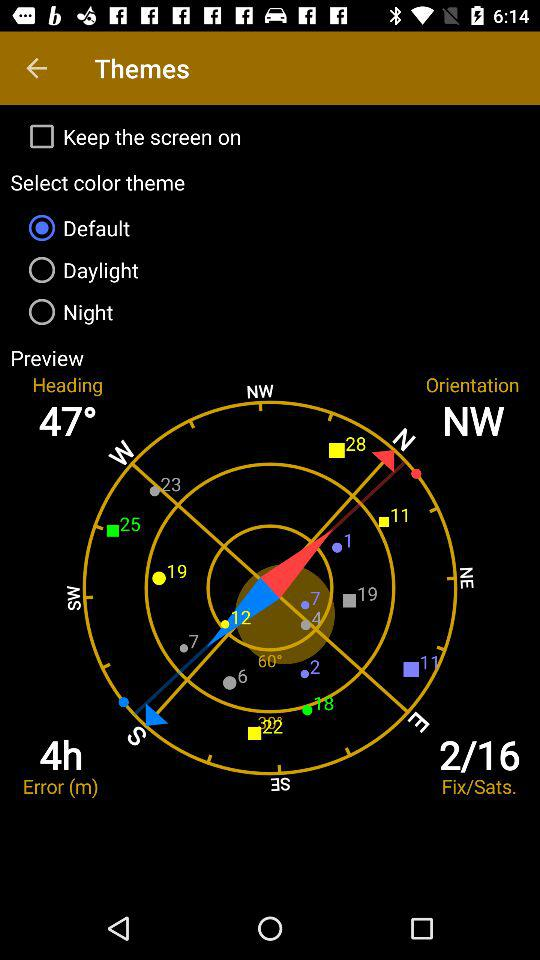What is the status of "Keep the screen on"? The status is "off". 